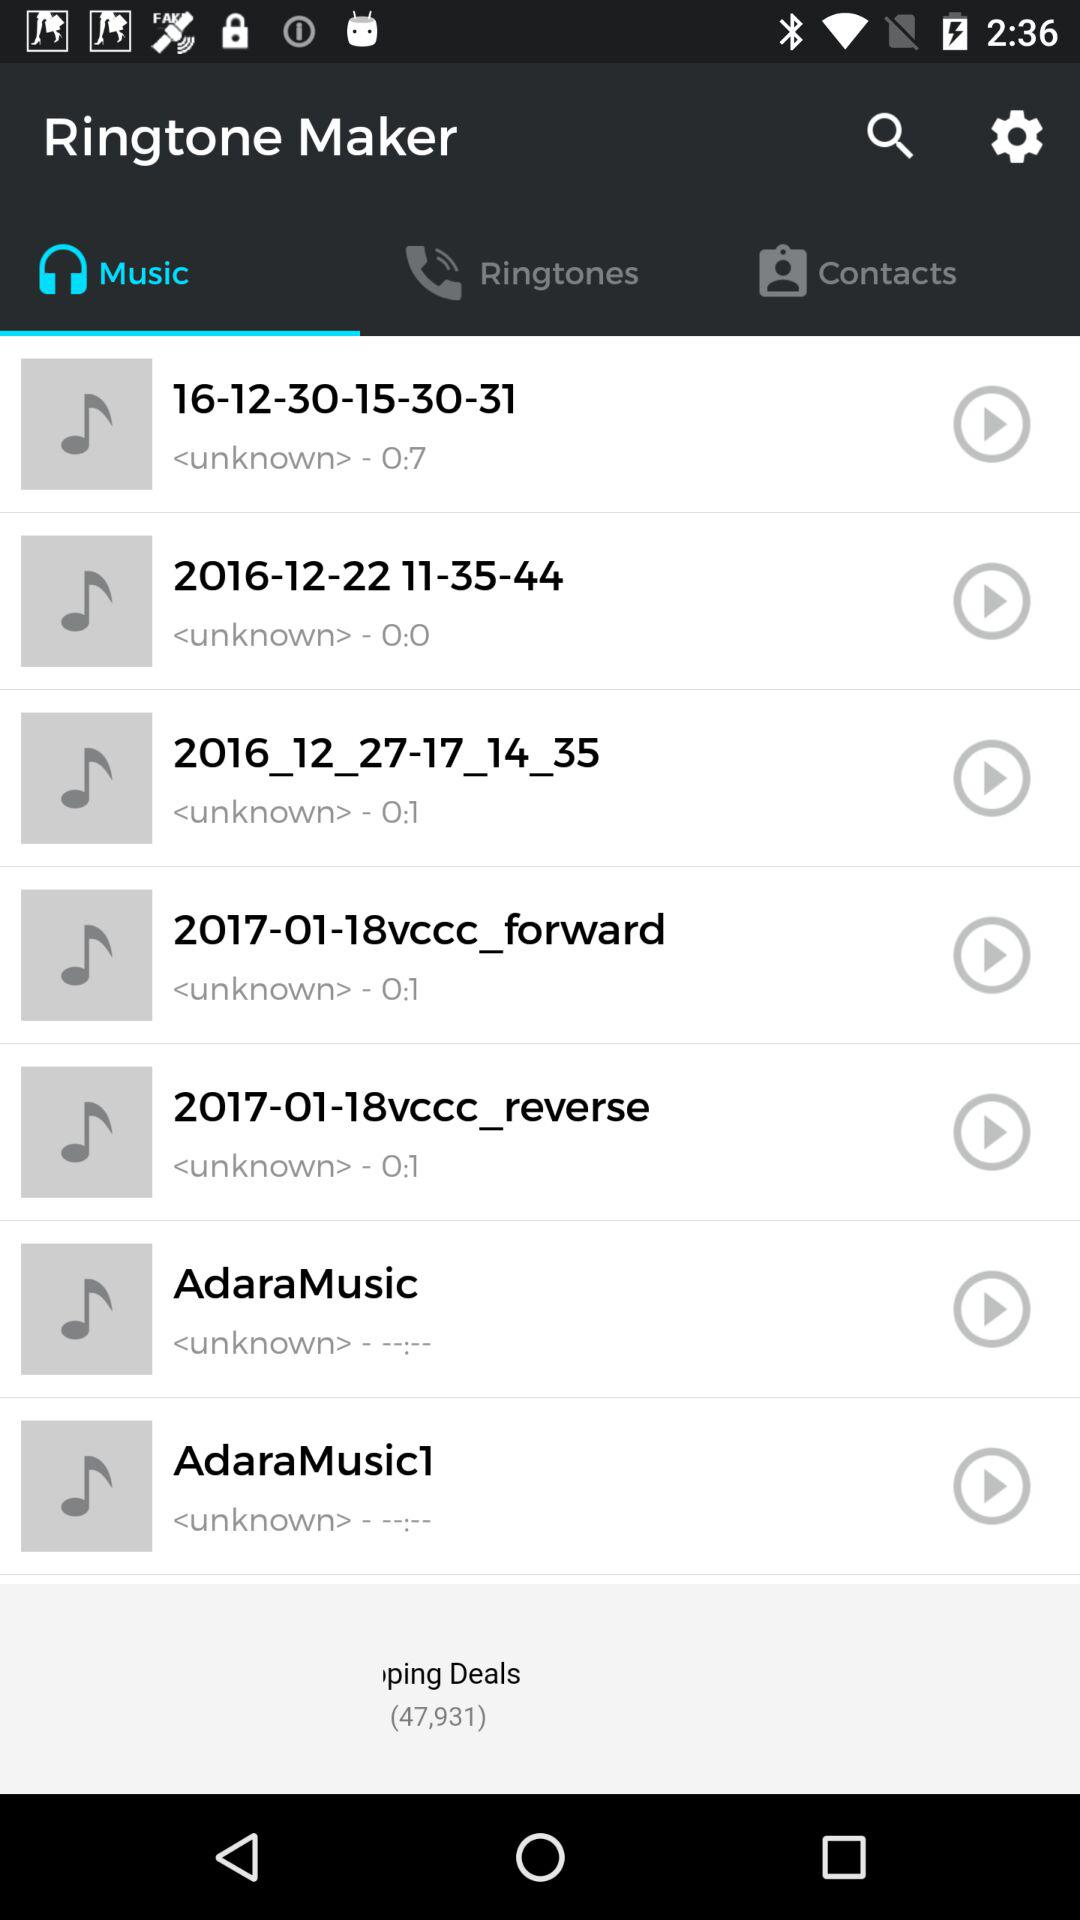Which tab is selected? The selected tab is "Music". 